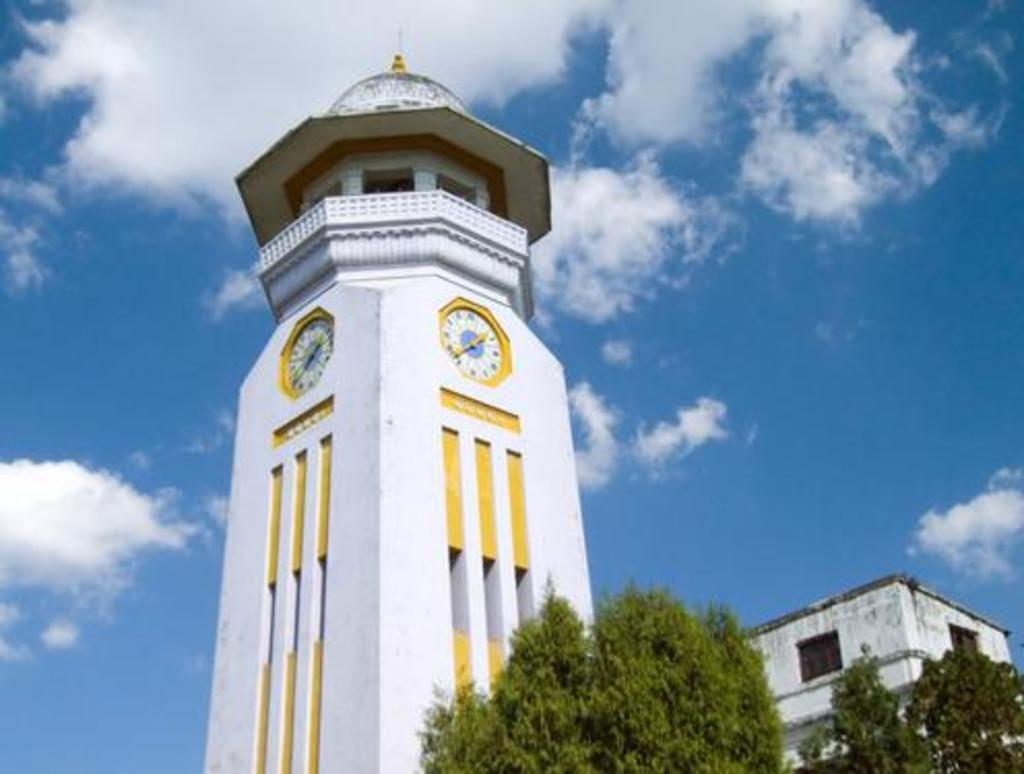What type of structures can be seen in the image? There are buildings in the image. What objects are hanging on the walls of the buildings? There are wall clocks in the image. What type of vegetation is visible in the image? There are trees in the image. What is visible in the background of the image? The sky is visible in the image. How would you describe the weather based on the appearance of the sky? The sky appears to be cloudy in the image. How many tents are set up in the image? There are no tents present in the image. What type of frogs can be seen hopping around the buildings in the image? There are no frogs present in the image. 